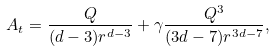Convert formula to latex. <formula><loc_0><loc_0><loc_500><loc_500>A _ { t } = \frac { Q } { ( d - 3 ) r ^ { d - 3 } } + \gamma \frac { Q ^ { 3 } } { ( 3 d - 7 ) r ^ { 3 d - 7 } } ,</formula> 